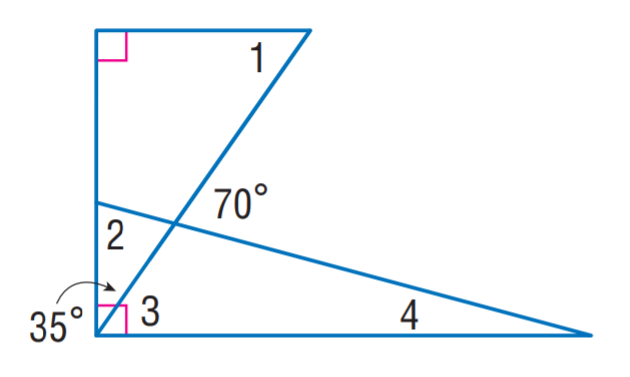Answer the mathemtical geometry problem and directly provide the correct option letter.
Question: Find m \angle 2.
Choices: A: 15 B: 55 C: 70 D: 75 D 